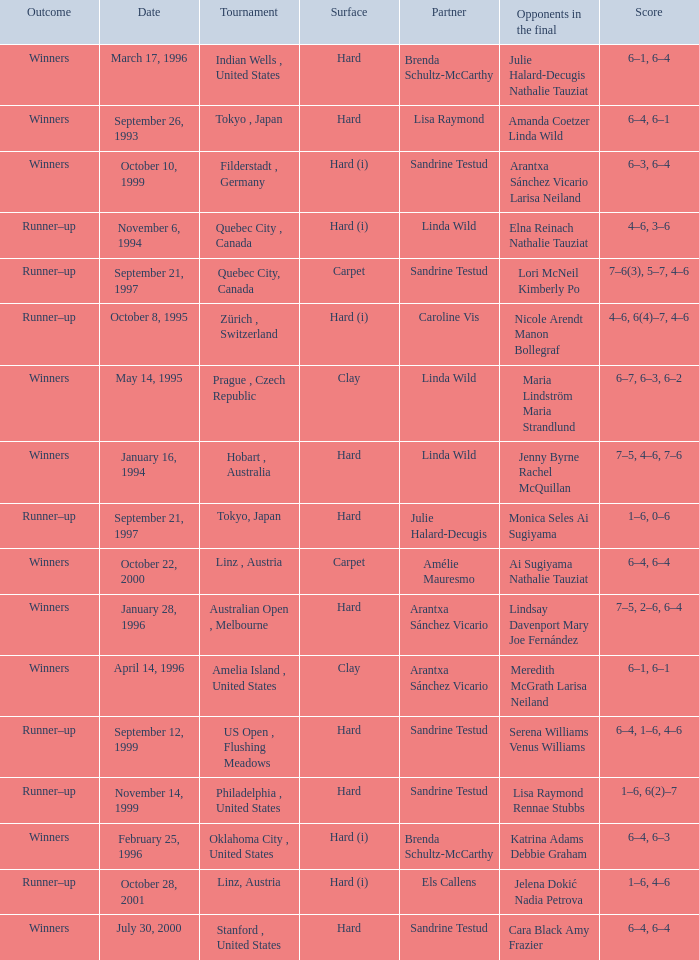Which surface had a partner of Sandrine Testud on November 14, 1999? Hard. 